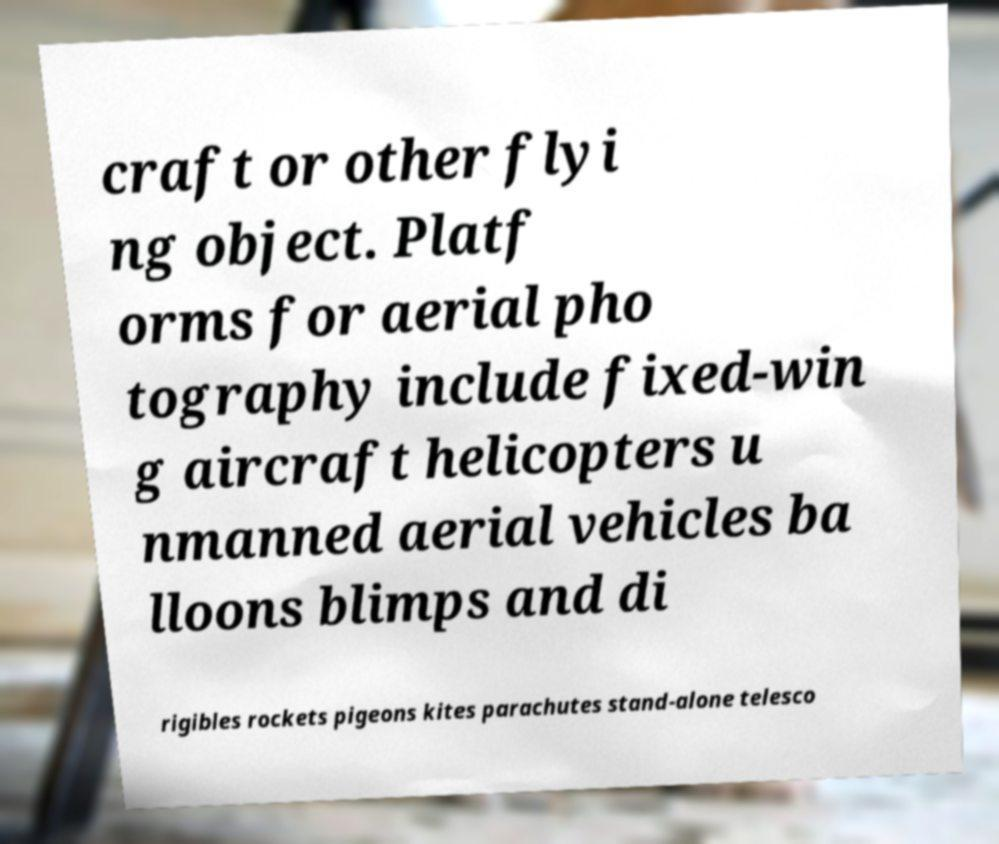Could you extract and type out the text from this image? craft or other flyi ng object. Platf orms for aerial pho tography include fixed-win g aircraft helicopters u nmanned aerial vehicles ba lloons blimps and di rigibles rockets pigeons kites parachutes stand-alone telesco 